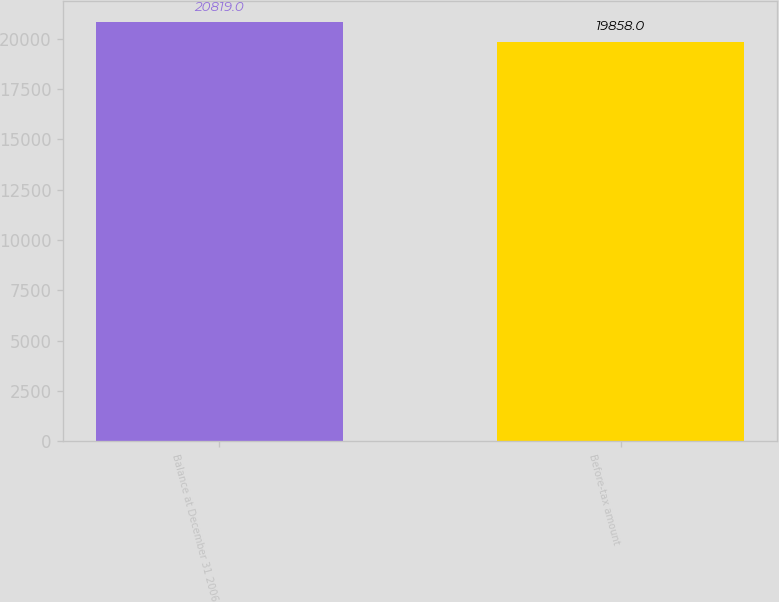<chart> <loc_0><loc_0><loc_500><loc_500><bar_chart><fcel>Balance at December 31 2006<fcel>Before-tax amount<nl><fcel>20819<fcel>19858<nl></chart> 